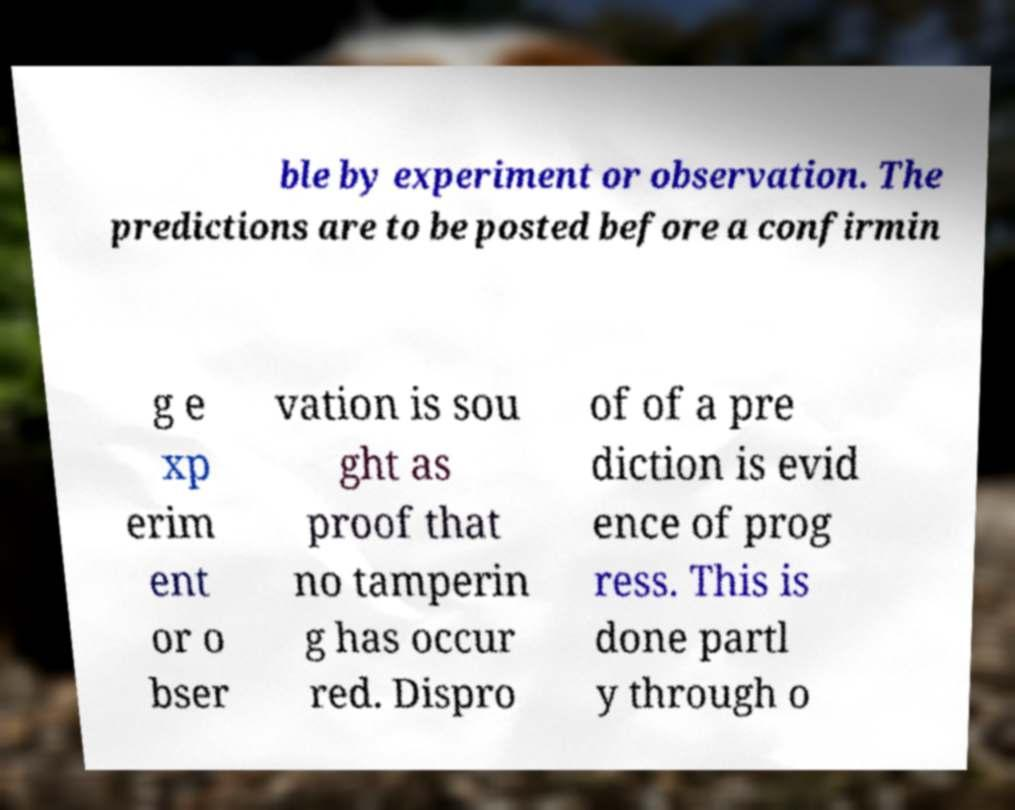Can you accurately transcribe the text from the provided image for me? ble by experiment or observation. The predictions are to be posted before a confirmin g e xp erim ent or o bser vation is sou ght as proof that no tamperin g has occur red. Dispro of of a pre diction is evid ence of prog ress. This is done partl y through o 